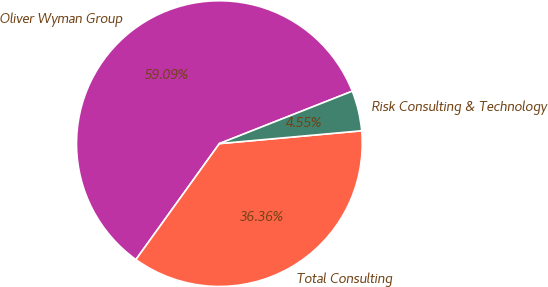Convert chart. <chart><loc_0><loc_0><loc_500><loc_500><pie_chart><fcel>Oliver Wyman Group<fcel>Total Consulting<fcel>Risk Consulting & Technology<nl><fcel>59.09%<fcel>36.36%<fcel>4.55%<nl></chart> 